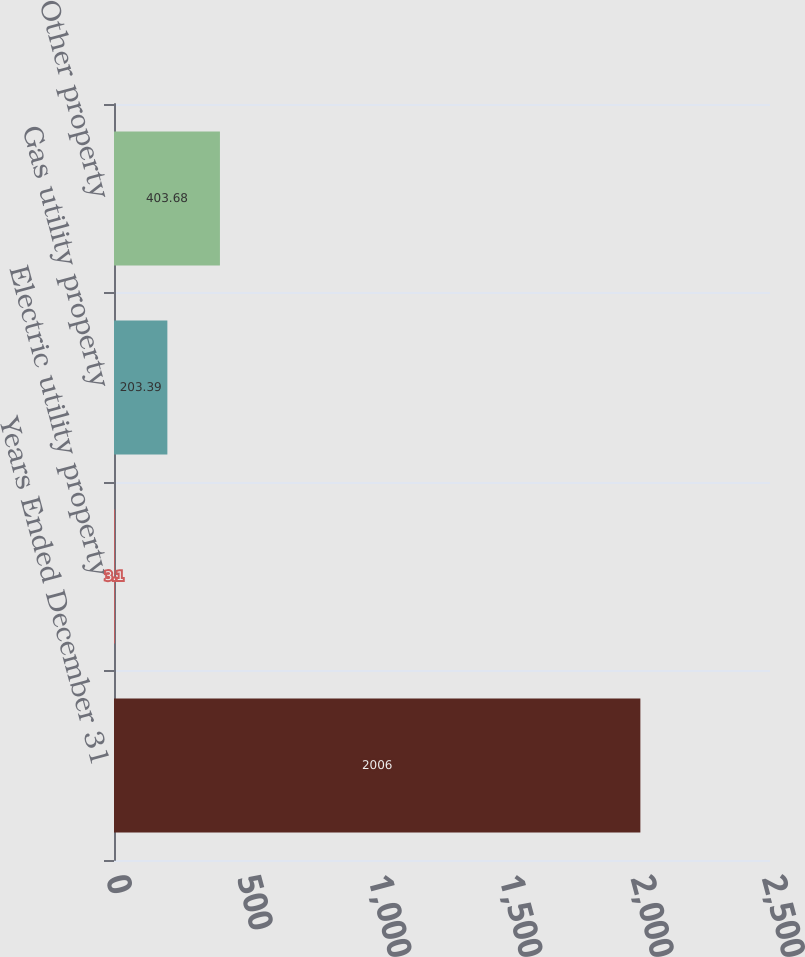<chart> <loc_0><loc_0><loc_500><loc_500><bar_chart><fcel>Years Ended December 31<fcel>Electric utility property<fcel>Gas utility property<fcel>Other property<nl><fcel>2006<fcel>3.1<fcel>203.39<fcel>403.68<nl></chart> 